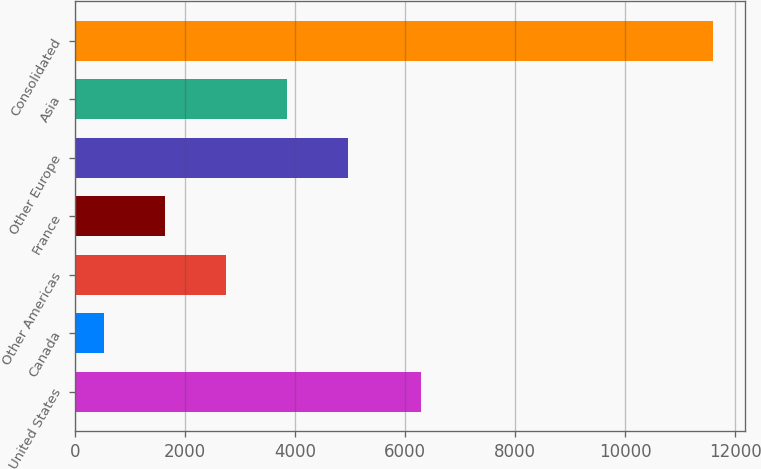Convert chart. <chart><loc_0><loc_0><loc_500><loc_500><bar_chart><fcel>United States<fcel>Canada<fcel>Other Americas<fcel>France<fcel>Other Europe<fcel>Asia<fcel>Consolidated<nl><fcel>6280.8<fcel>519.8<fcel>2734.54<fcel>1627.17<fcel>4949.28<fcel>3841.91<fcel>11593.5<nl></chart> 